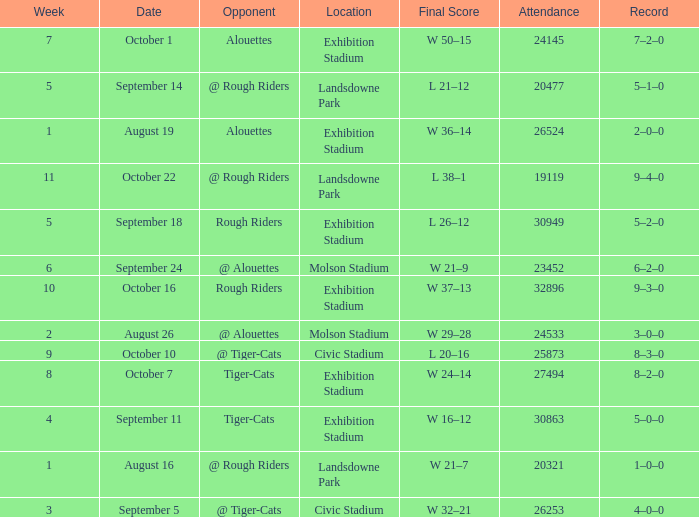How many values for attendance on the date of August 26? 1.0. 